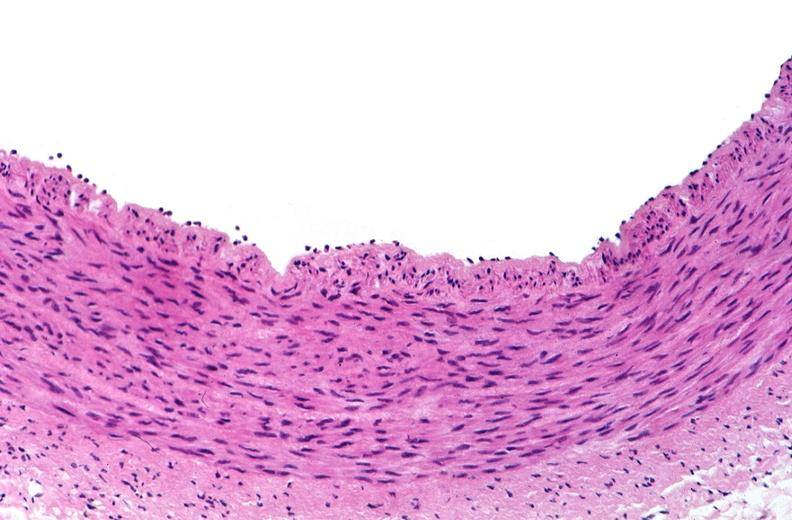where is this from?
Answer the question using a single word or phrase. Vasculature 